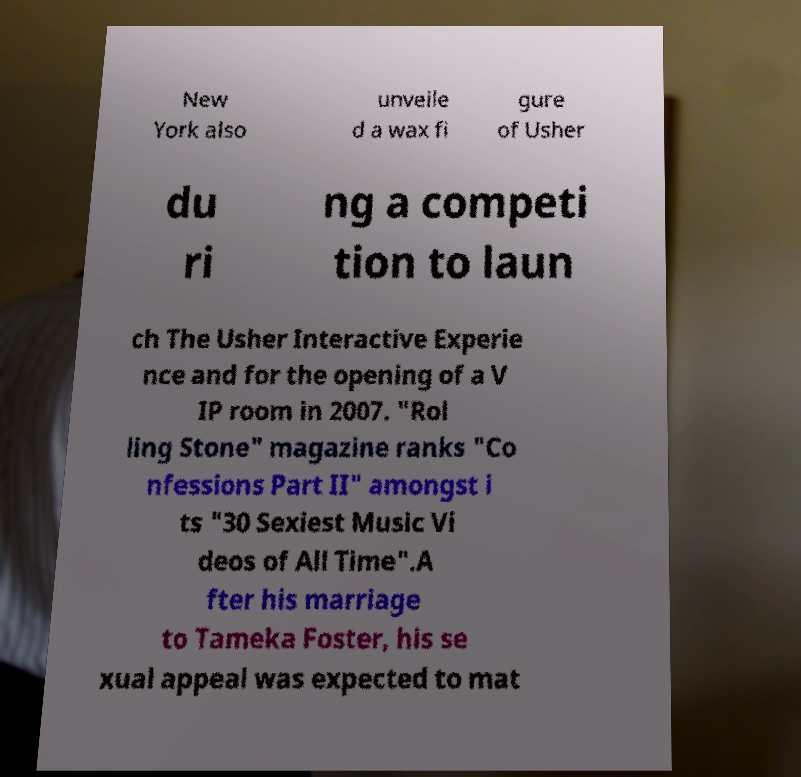Please identify and transcribe the text found in this image. New York also unveile d a wax fi gure of Usher du ri ng a competi tion to laun ch The Usher Interactive Experie nce and for the opening of a V IP room in 2007. "Rol ling Stone" magazine ranks "Co nfessions Part II" amongst i ts "30 Sexiest Music Vi deos of All Time".A fter his marriage to Tameka Foster, his se xual appeal was expected to mat 